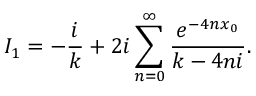Convert formula to latex. <formula><loc_0><loc_0><loc_500><loc_500>I _ { 1 } = - \frac { i } { k } + 2 i \sum _ { n = 0 } ^ { \infty } \frac { e ^ { - 4 n x _ { 0 } } } { k - 4 n i } .</formula> 